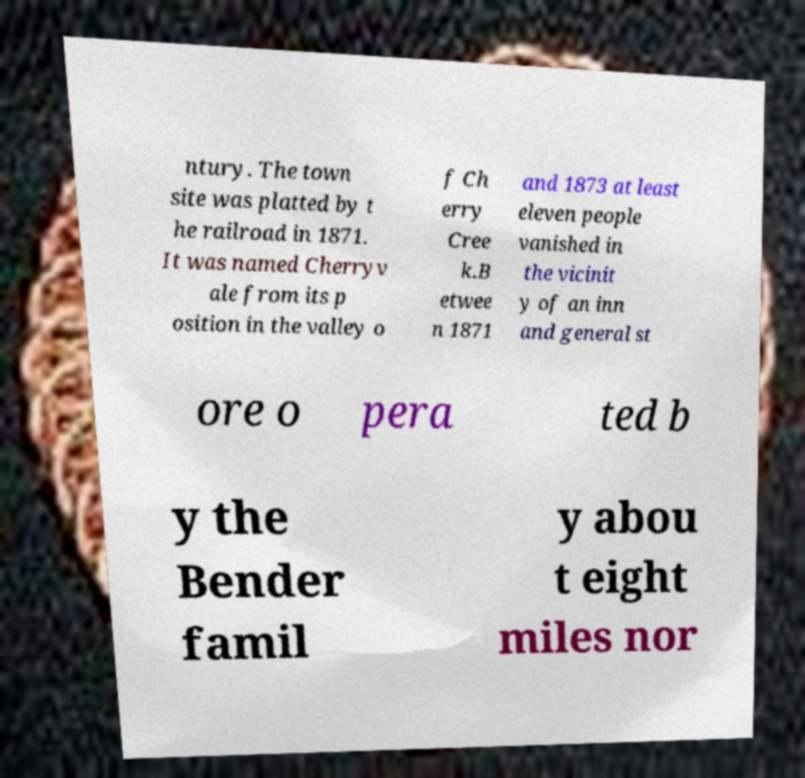What messages or text are displayed in this image? I need them in a readable, typed format. ntury. The town site was platted by t he railroad in 1871. It was named Cherryv ale from its p osition in the valley o f Ch erry Cree k.B etwee n 1871 and 1873 at least eleven people vanished in the vicinit y of an inn and general st ore o pera ted b y the Bender famil y abou t eight miles nor 